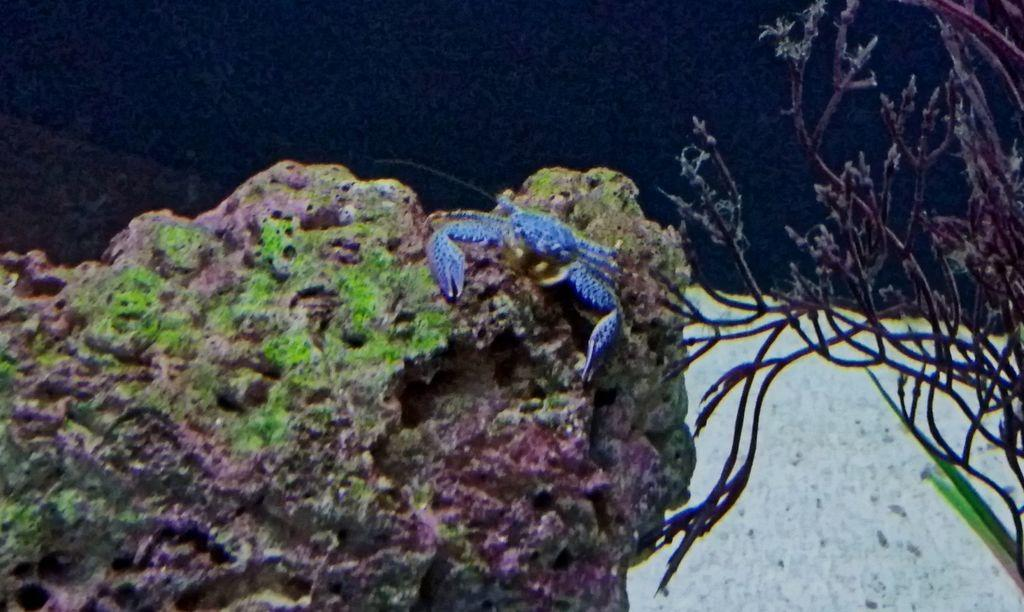What is the main subject in the center of the image? There is a stone in the center of the image. What is on top of the stone? There is a crab on the stone. What color is the crab? The crab is dark blue in color. What can be seen in the background of the image? There is a plant visible in the background of the image, along with a few other objects. What type of underwear is the crab wearing in the image? Crabs do not wear underwear, and there is no underwear present in the image. What game is being played by the crab in the image? There is no game being played in the image; the crab is simply sitting on the stone. 